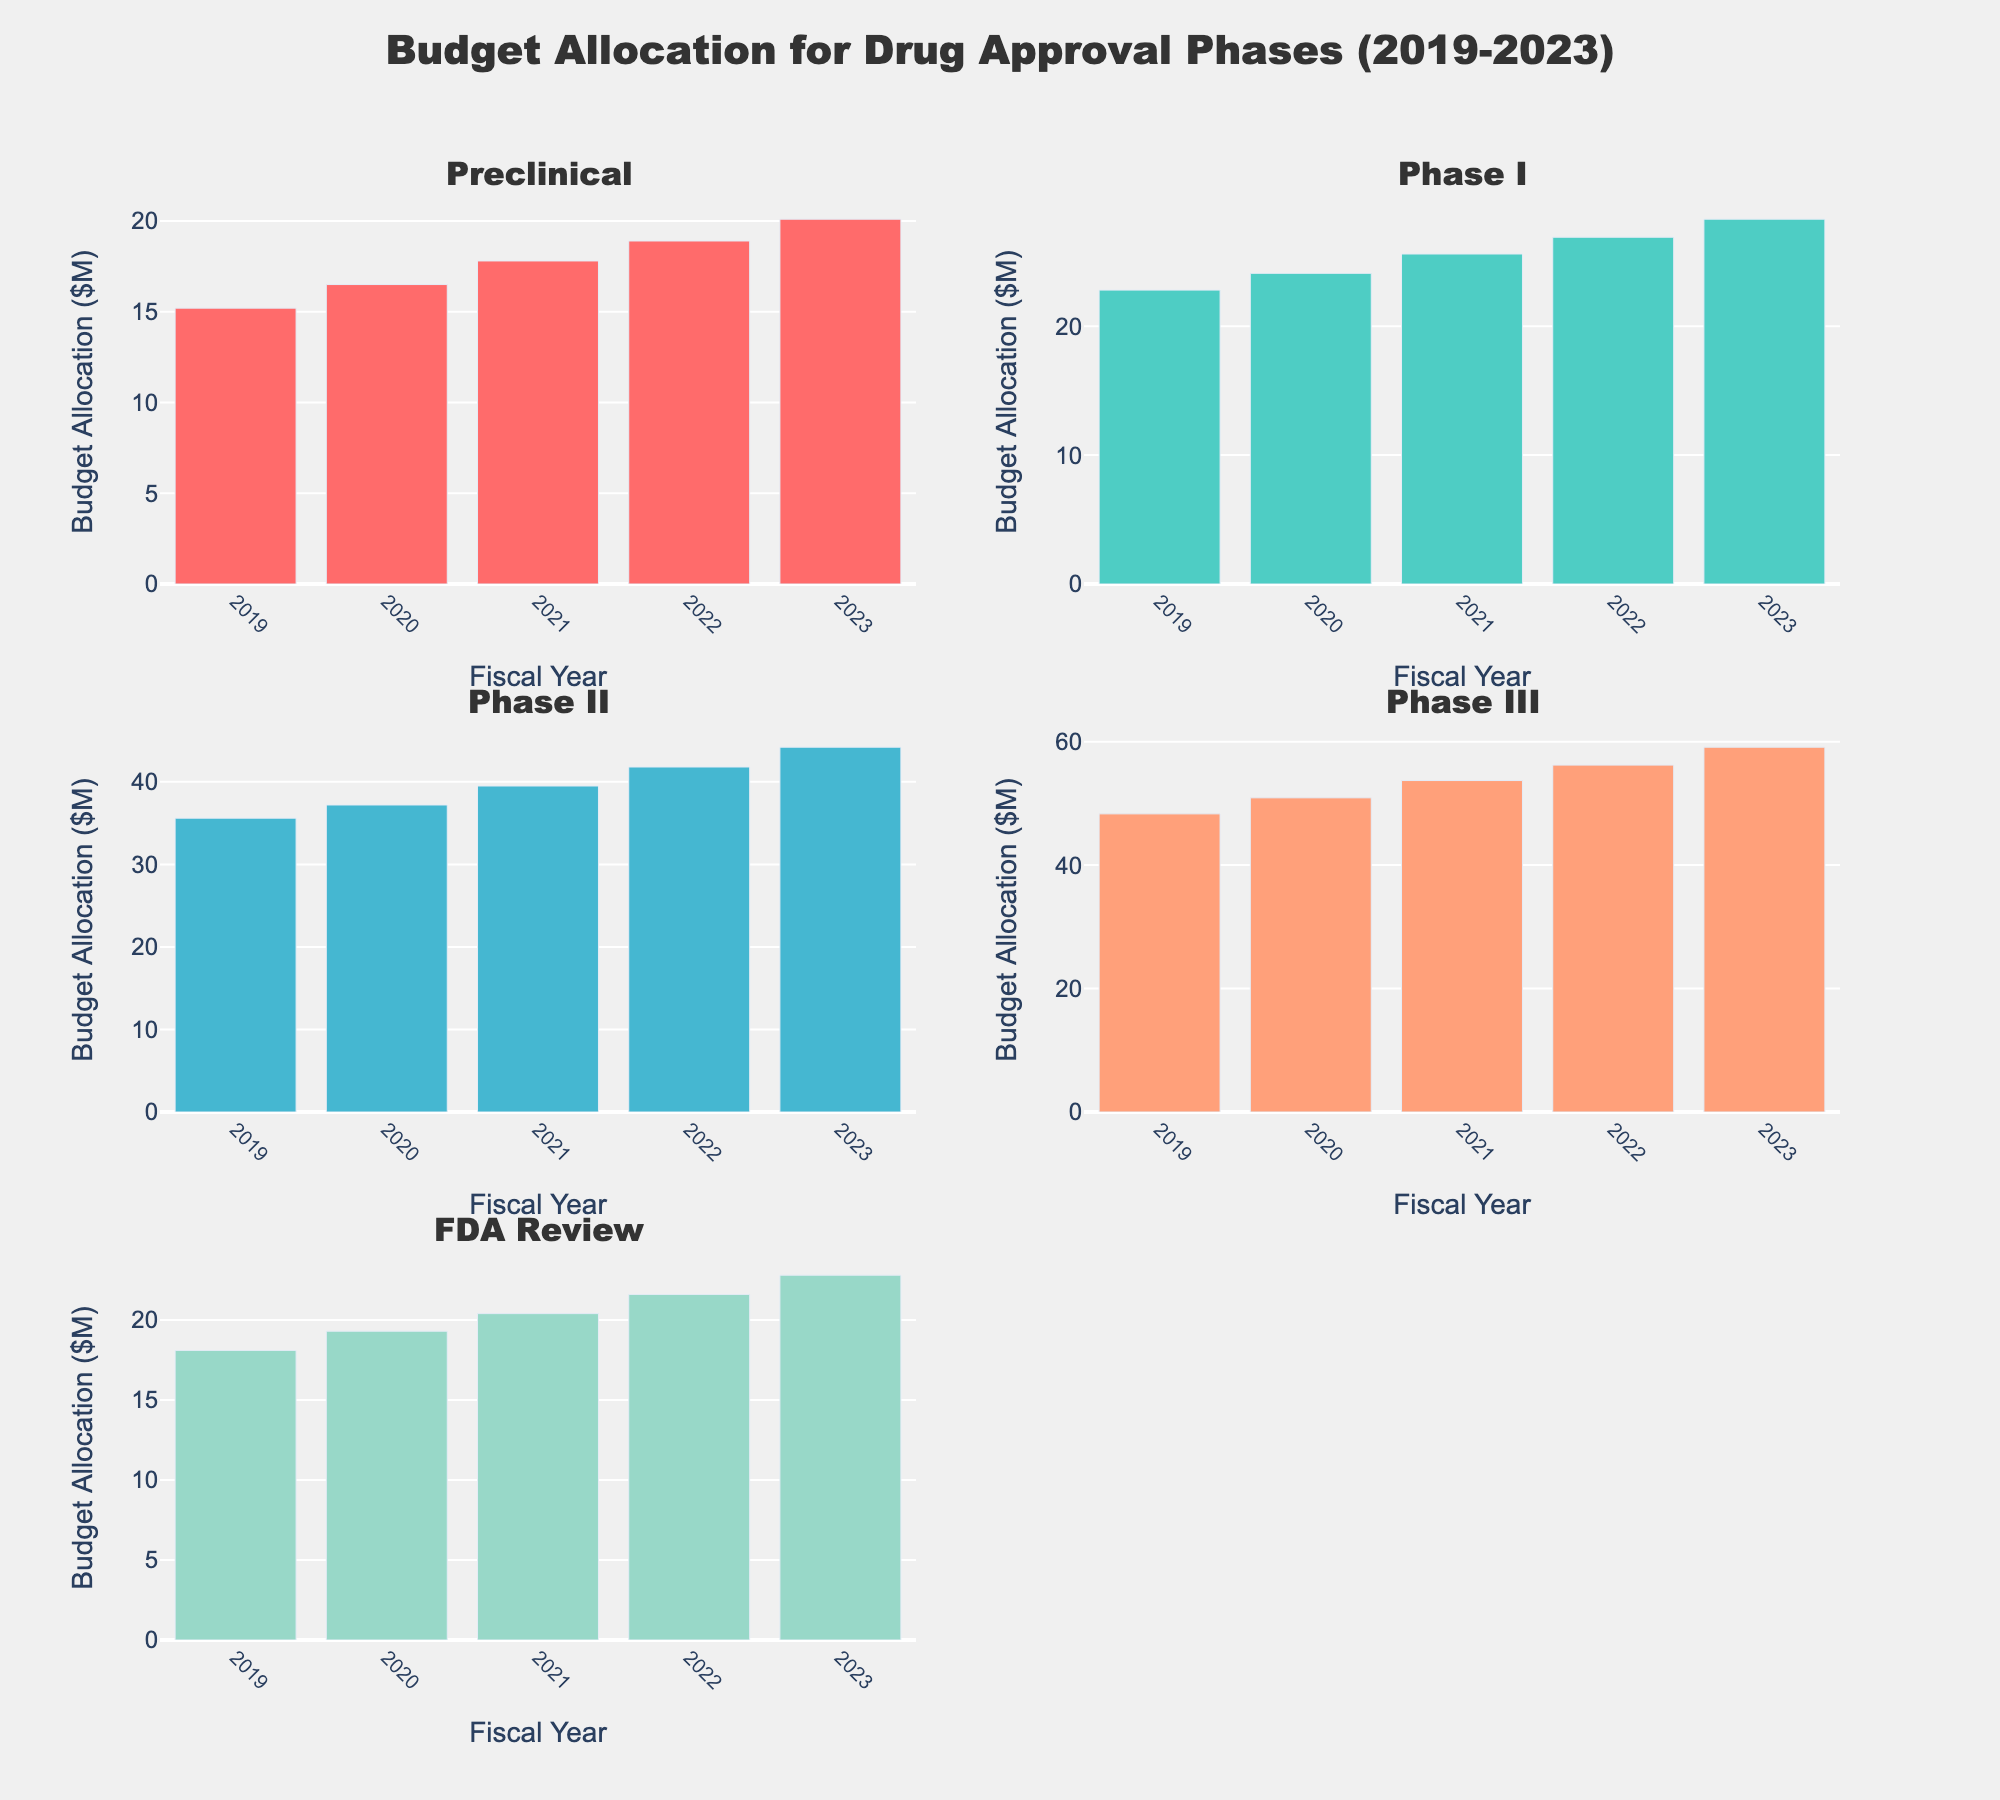What is the title of the figure? The title is displayed at the top of the figure. It reads "Budget Allocation for Drug Approval Phases (2019-2023)"
Answer: Budget Allocation for Drug Approval Phases (2019-2023) Which fiscal year has the highest budget allocation for Phase III? By examining the bars in the subplot for Phase III, the highest bar represents the year 2023
Answer: 2023 How much did the budget for Preclinical increase from 2019 to 2023? The budget for Preclinical in 2019 is 15.2M and in 2023 is 20.1M. The increase is 20.1 - 15.2
Answer: 4.9M Which phase consistently received an increasing budget allocation each year? By comparing the heights of the bars in each subplot, we see that all phases (Preclinical, Phase I, Phase II, Phase III, FDA Review) have increasing budget allocations each year
Answer: All phases Compare the budget allocation for FDA Review in 2021 with Phase I in 2022. Which received more funding? The budget for FDA Review in 2021 is 20.4M, and for Phase I in 2022 is 26.9M. Phase I in 2022 received more funding than FDA Review in 2021
Answer: Phase I in 2022 What is the total budget allocation for Phase II over the 5 years? Add the values for Phase II from 2019 to 2023: 35.6 + 37.2 + 39.5 + 41.8 + 44.2 = 198.3M
Answer: 198.3M Which phase had the smallest increase in budget from 2019 to 2020? Look at the increase in budget: Preclinical (16.5-15.2), Phase I (24.1-22.8), Phase II (37.2-35.6), Phase III (50.9-48.3), FDA Review (19.3-18.1). The smallest increase is for FDA Review (19.3 - 18.1 = 1.2M)
Answer: FDA Review How does the budget allocation for Phase II in 2020 compare to the budget for Phase III in the same year? The budget for Phase II in 2020 is 37.2M and for Phase III is 50.9M. Phase III has a higher budget
Answer: Phase III in 2020 What is the average budget allocation for Phase I over the years 2019 to 2023? The budget allocations for Phase I are 22.8, 24.1, 25.6, 26.9, and 28.3. The average is (22.8 + 24.1 + 25.6 + 26.9 + 28.3)/5 = 25.54M
Answer: 25.54M 